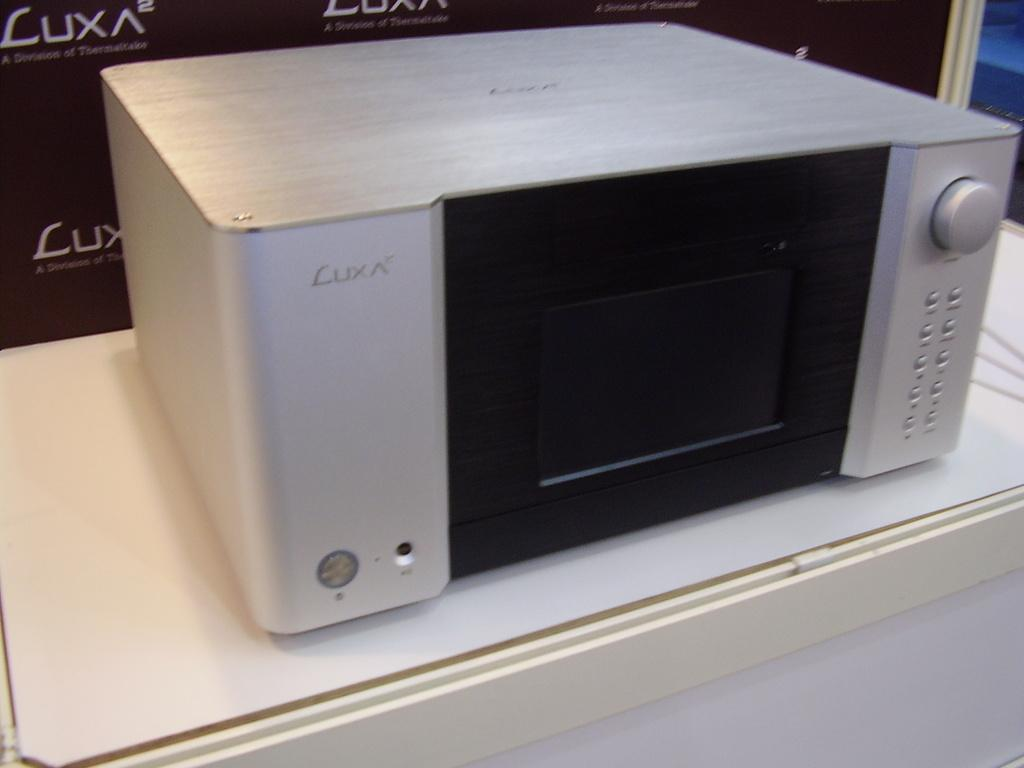<image>
Share a concise interpretation of the image provided. A LUXA logo can be seen on a microwave and the box behind it. 